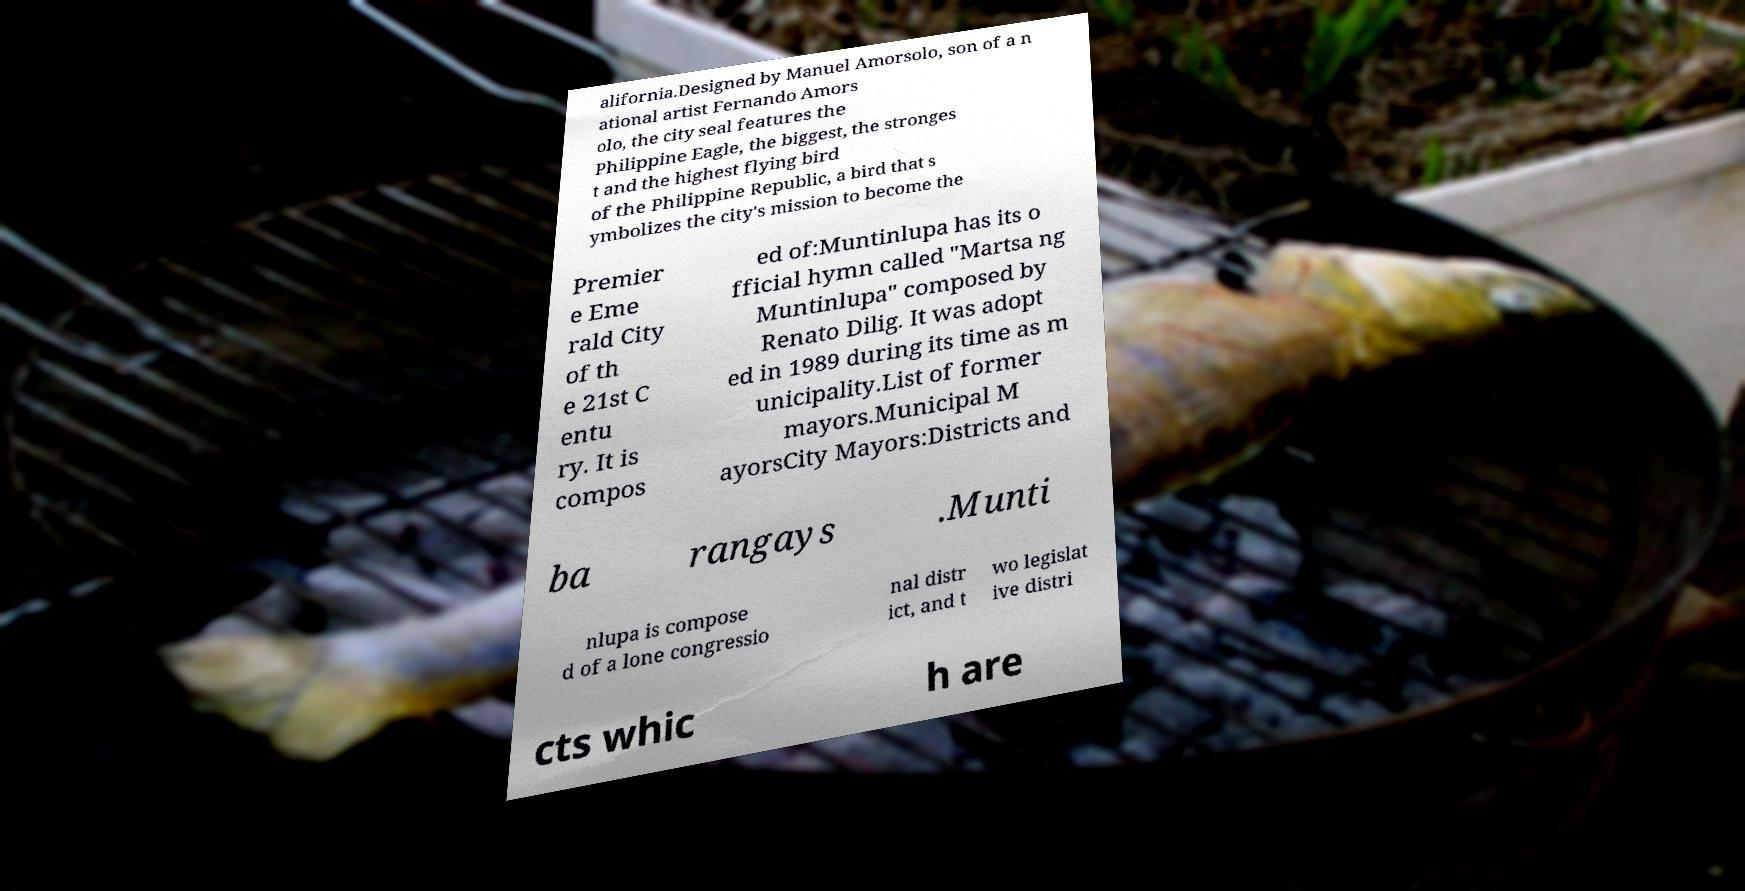There's text embedded in this image that I need extracted. Can you transcribe it verbatim? alifornia.Designed by Manuel Amorsolo, son of a n ational artist Fernando Amors olo, the city seal features the Philippine Eagle, the biggest, the stronges t and the highest flying bird of the Philippine Republic, a bird that s ymbolizes the city's mission to become the Premier e Eme rald City of th e 21st C entu ry. It is compos ed of:Muntinlupa has its o fficial hymn called "Martsa ng Muntinlupa" composed by Renato Dilig. It was adopt ed in 1989 during its time as m unicipality.List of former mayors.Municipal M ayorsCity Mayors:Districts and ba rangays .Munti nlupa is compose d of a lone congressio nal distr ict, and t wo legislat ive distri cts whic h are 